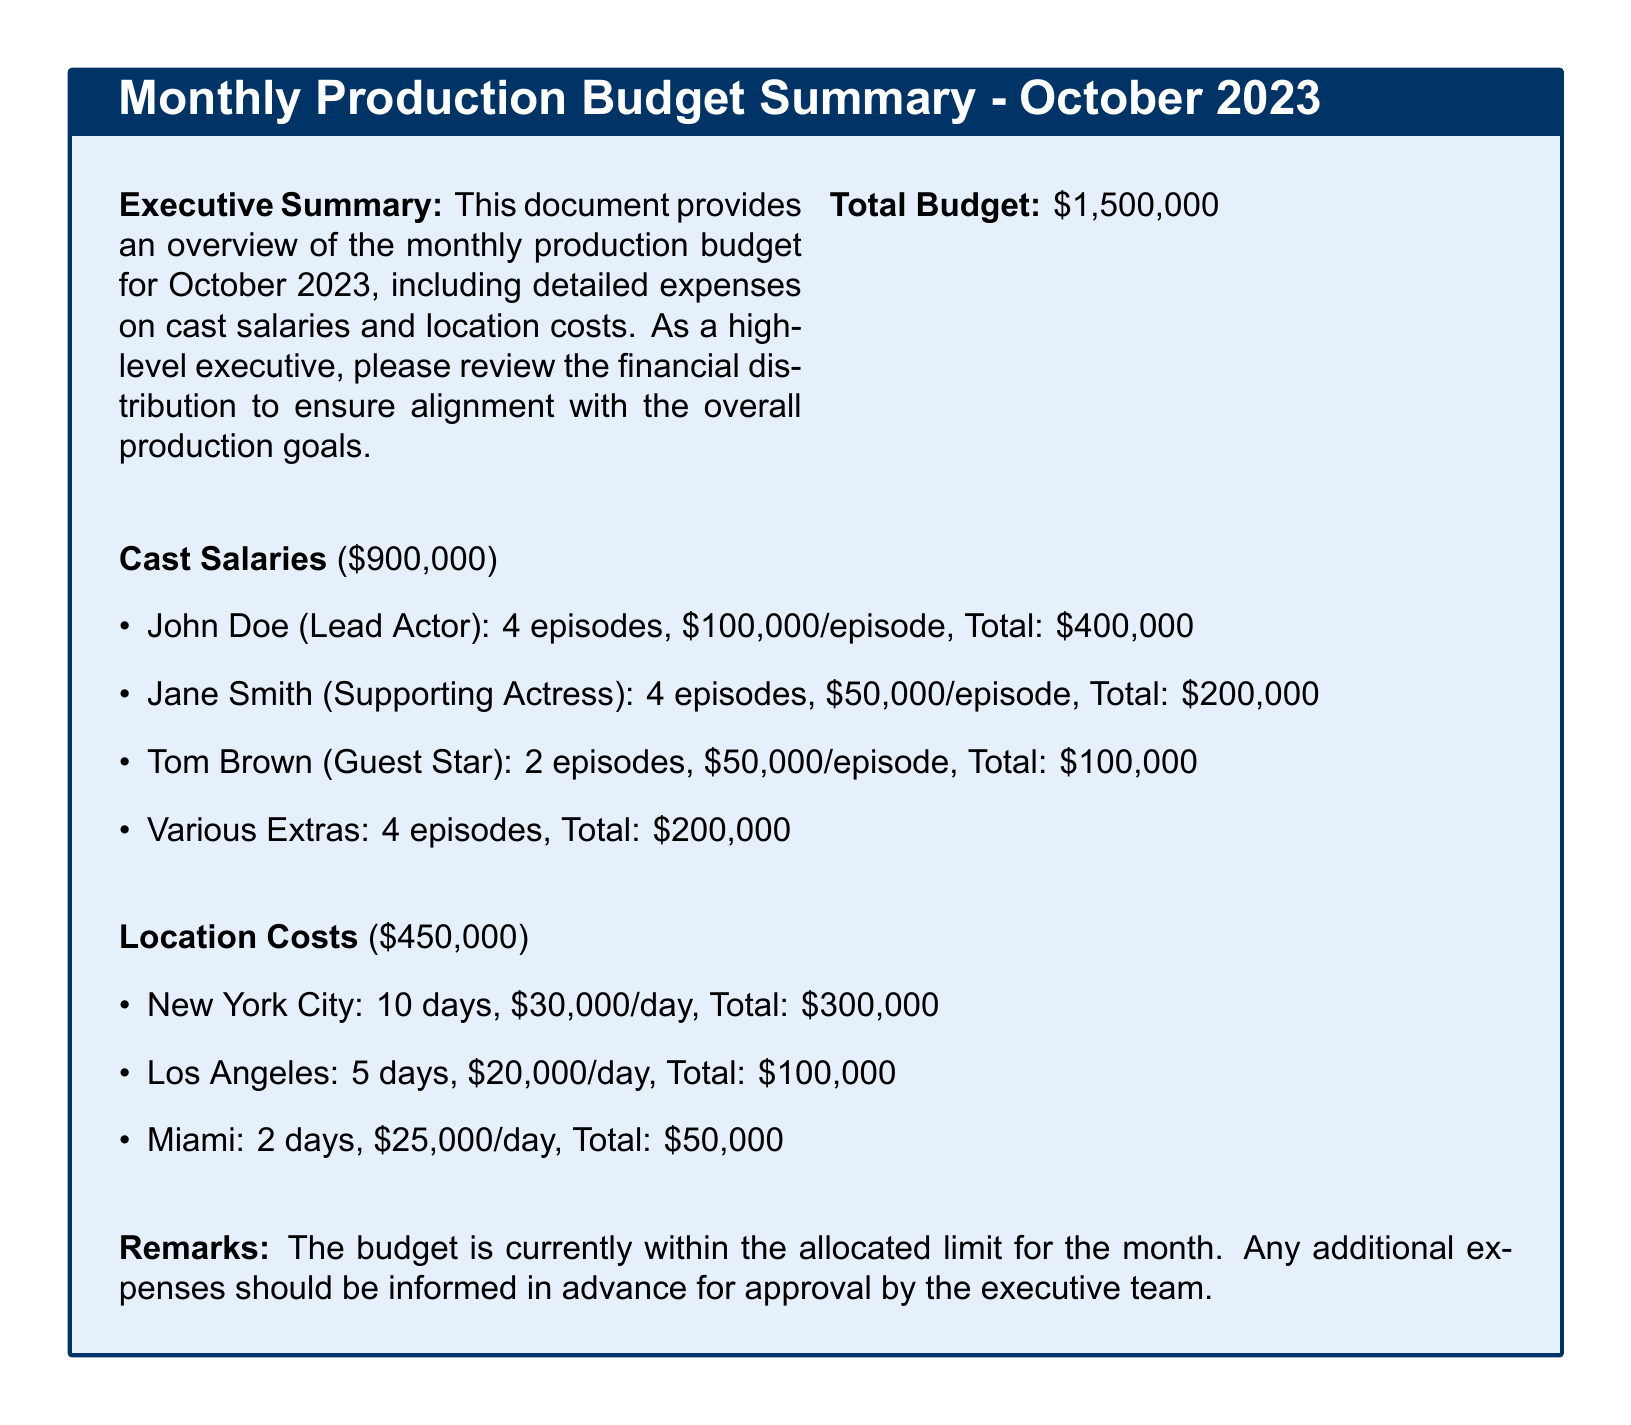What is the total budget for October 2023? The total budget is stated directly in the document.
Answer: $1,500,000 Who is the lead actor and what is their total salary? The lead actor is named in the Cast Salaries section, and their total salary is calculated from the per episode rate and number of episodes.
Answer: John Doe, $400,000 How many episodes did Jane Smith appear in? Jane Smith's contribution to the cast salaries specifies the number of episodes she appeared in.
Answer: 4 episodes What are the location costs associated with New York City? The document provides details about the location costs, including the number of days and daily cost.
Answer: $300,000 What is the total cost for various extras? The document lists the expenses associated with extras explicitly in the Cast Salaries section.
Answer: $200,000 How many days are allocated for filming in Los Angeles? The location costs section explicitly states the number of days allocated for Los Angeles filming.
Answer: 5 days What is the total for location costs? The total for location costs is given directly in the document.
Answer: $450,000 What should be done if there are additional expenses? The remarks section emphasizes the protocol for additional expenses.
Answer: Inform in advance for approval 